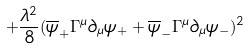<formula> <loc_0><loc_0><loc_500><loc_500>+ \frac { \lambda ^ { 2 } } { 8 } ( \overline { \psi } _ { + } \Gamma ^ { \mu } \partial _ { \mu } \psi _ { + } + \overline { \psi } _ { - } \Gamma ^ { \mu } \partial _ { \mu } \psi _ { - } ) ^ { 2 }</formula> 